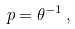<formula> <loc_0><loc_0><loc_500><loc_500>p = \theta ^ { - 1 } \, ,</formula> 